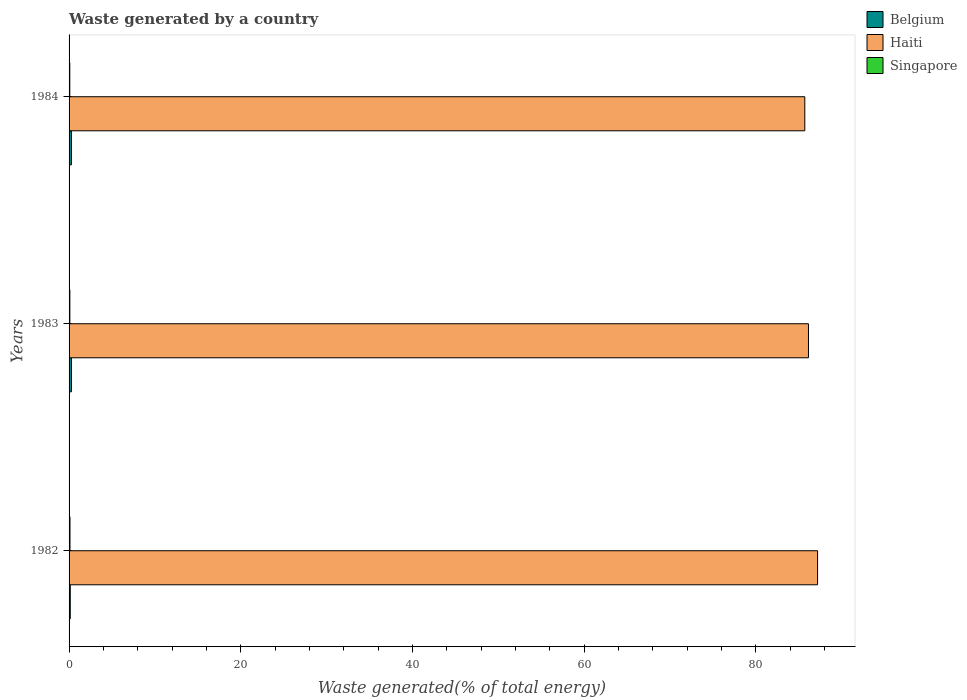How many groups of bars are there?
Offer a very short reply. 3. How many bars are there on the 3rd tick from the top?
Your answer should be compact. 3. How many bars are there on the 2nd tick from the bottom?
Make the answer very short. 3. What is the total waste generated in Belgium in 1984?
Ensure brevity in your answer.  0.27. Across all years, what is the maximum total waste generated in Haiti?
Your answer should be very brief. 87.19. Across all years, what is the minimum total waste generated in Belgium?
Give a very brief answer. 0.14. In which year was the total waste generated in Haiti maximum?
Your answer should be very brief. 1982. What is the total total waste generated in Haiti in the graph?
Provide a short and direct response. 259.02. What is the difference between the total waste generated in Belgium in 1982 and that in 1983?
Provide a succinct answer. -0.14. What is the difference between the total waste generated in Singapore in 1984 and the total waste generated in Haiti in 1982?
Provide a short and direct response. -87.11. What is the average total waste generated in Belgium per year?
Offer a very short reply. 0.23. In the year 1982, what is the difference between the total waste generated in Haiti and total waste generated in Singapore?
Your response must be concise. 87.08. What is the ratio of the total waste generated in Belgium in 1982 to that in 1984?
Your answer should be compact. 0.51. Is the difference between the total waste generated in Haiti in 1982 and 1983 greater than the difference between the total waste generated in Singapore in 1982 and 1983?
Your response must be concise. Yes. What is the difference between the highest and the second highest total waste generated in Belgium?
Your answer should be compact. 0. What is the difference between the highest and the lowest total waste generated in Singapore?
Ensure brevity in your answer.  0.02. What does the 3rd bar from the bottom in 1984 represents?
Ensure brevity in your answer.  Singapore. How many bars are there?
Provide a succinct answer. 9. Are all the bars in the graph horizontal?
Make the answer very short. Yes. Does the graph contain any zero values?
Give a very brief answer. No. Does the graph contain grids?
Ensure brevity in your answer.  No. How are the legend labels stacked?
Your answer should be compact. Vertical. What is the title of the graph?
Offer a very short reply. Waste generated by a country. Does "Micronesia" appear as one of the legend labels in the graph?
Provide a succinct answer. No. What is the label or title of the X-axis?
Offer a very short reply. Waste generated(% of total energy). What is the Waste generated(% of total energy) of Belgium in 1982?
Ensure brevity in your answer.  0.14. What is the Waste generated(% of total energy) in Haiti in 1982?
Your answer should be compact. 87.19. What is the Waste generated(% of total energy) of Singapore in 1982?
Provide a short and direct response. 0.11. What is the Waste generated(% of total energy) of Belgium in 1983?
Offer a terse response. 0.28. What is the Waste generated(% of total energy) of Haiti in 1983?
Make the answer very short. 86.13. What is the Waste generated(% of total energy) in Singapore in 1983?
Ensure brevity in your answer.  0.09. What is the Waste generated(% of total energy) of Belgium in 1984?
Give a very brief answer. 0.27. What is the Waste generated(% of total energy) in Haiti in 1984?
Keep it short and to the point. 85.7. What is the Waste generated(% of total energy) of Singapore in 1984?
Make the answer very short. 0.08. Across all years, what is the maximum Waste generated(% of total energy) of Belgium?
Offer a very short reply. 0.28. Across all years, what is the maximum Waste generated(% of total energy) in Haiti?
Your answer should be very brief. 87.19. Across all years, what is the maximum Waste generated(% of total energy) of Singapore?
Provide a short and direct response. 0.11. Across all years, what is the minimum Waste generated(% of total energy) in Belgium?
Ensure brevity in your answer.  0.14. Across all years, what is the minimum Waste generated(% of total energy) of Haiti?
Ensure brevity in your answer.  85.7. Across all years, what is the minimum Waste generated(% of total energy) of Singapore?
Offer a very short reply. 0.08. What is the total Waste generated(% of total energy) of Belgium in the graph?
Offer a very short reply. 0.69. What is the total Waste generated(% of total energy) in Haiti in the graph?
Offer a very short reply. 259.02. What is the total Waste generated(% of total energy) of Singapore in the graph?
Your answer should be compact. 0.28. What is the difference between the Waste generated(% of total energy) in Belgium in 1982 and that in 1983?
Your answer should be very brief. -0.14. What is the difference between the Waste generated(% of total energy) in Haiti in 1982 and that in 1983?
Offer a terse response. 1.06. What is the difference between the Waste generated(% of total energy) of Singapore in 1982 and that in 1983?
Keep it short and to the point. 0.01. What is the difference between the Waste generated(% of total energy) in Belgium in 1982 and that in 1984?
Provide a succinct answer. -0.14. What is the difference between the Waste generated(% of total energy) in Haiti in 1982 and that in 1984?
Your answer should be compact. 1.49. What is the difference between the Waste generated(% of total energy) in Singapore in 1982 and that in 1984?
Keep it short and to the point. 0.02. What is the difference between the Waste generated(% of total energy) of Belgium in 1983 and that in 1984?
Offer a terse response. 0. What is the difference between the Waste generated(% of total energy) of Haiti in 1983 and that in 1984?
Make the answer very short. 0.43. What is the difference between the Waste generated(% of total energy) of Singapore in 1983 and that in 1984?
Give a very brief answer. 0.01. What is the difference between the Waste generated(% of total energy) of Belgium in 1982 and the Waste generated(% of total energy) of Haiti in 1983?
Provide a short and direct response. -85.99. What is the difference between the Waste generated(% of total energy) of Belgium in 1982 and the Waste generated(% of total energy) of Singapore in 1983?
Offer a very short reply. 0.05. What is the difference between the Waste generated(% of total energy) of Haiti in 1982 and the Waste generated(% of total energy) of Singapore in 1983?
Give a very brief answer. 87.1. What is the difference between the Waste generated(% of total energy) in Belgium in 1982 and the Waste generated(% of total energy) in Haiti in 1984?
Offer a very short reply. -85.56. What is the difference between the Waste generated(% of total energy) in Belgium in 1982 and the Waste generated(% of total energy) in Singapore in 1984?
Make the answer very short. 0.06. What is the difference between the Waste generated(% of total energy) in Haiti in 1982 and the Waste generated(% of total energy) in Singapore in 1984?
Make the answer very short. 87.11. What is the difference between the Waste generated(% of total energy) in Belgium in 1983 and the Waste generated(% of total energy) in Haiti in 1984?
Ensure brevity in your answer.  -85.42. What is the difference between the Waste generated(% of total energy) of Belgium in 1983 and the Waste generated(% of total energy) of Singapore in 1984?
Your response must be concise. 0.2. What is the difference between the Waste generated(% of total energy) in Haiti in 1983 and the Waste generated(% of total energy) in Singapore in 1984?
Offer a very short reply. 86.05. What is the average Waste generated(% of total energy) of Belgium per year?
Make the answer very short. 0.23. What is the average Waste generated(% of total energy) in Haiti per year?
Your answer should be very brief. 86.34. What is the average Waste generated(% of total energy) in Singapore per year?
Offer a very short reply. 0.09. In the year 1982, what is the difference between the Waste generated(% of total energy) in Belgium and Waste generated(% of total energy) in Haiti?
Your response must be concise. -87.05. In the year 1982, what is the difference between the Waste generated(% of total energy) in Belgium and Waste generated(% of total energy) in Singapore?
Offer a very short reply. 0.03. In the year 1982, what is the difference between the Waste generated(% of total energy) in Haiti and Waste generated(% of total energy) in Singapore?
Give a very brief answer. 87.08. In the year 1983, what is the difference between the Waste generated(% of total energy) of Belgium and Waste generated(% of total energy) of Haiti?
Your answer should be very brief. -85.85. In the year 1983, what is the difference between the Waste generated(% of total energy) of Belgium and Waste generated(% of total energy) of Singapore?
Provide a succinct answer. 0.19. In the year 1983, what is the difference between the Waste generated(% of total energy) of Haiti and Waste generated(% of total energy) of Singapore?
Keep it short and to the point. 86.04. In the year 1984, what is the difference between the Waste generated(% of total energy) of Belgium and Waste generated(% of total energy) of Haiti?
Ensure brevity in your answer.  -85.43. In the year 1984, what is the difference between the Waste generated(% of total energy) of Belgium and Waste generated(% of total energy) of Singapore?
Your answer should be very brief. 0.19. In the year 1984, what is the difference between the Waste generated(% of total energy) in Haiti and Waste generated(% of total energy) in Singapore?
Make the answer very short. 85.62. What is the ratio of the Waste generated(% of total energy) of Belgium in 1982 to that in 1983?
Your response must be concise. 0.5. What is the ratio of the Waste generated(% of total energy) of Haiti in 1982 to that in 1983?
Keep it short and to the point. 1.01. What is the ratio of the Waste generated(% of total energy) of Singapore in 1982 to that in 1983?
Make the answer very short. 1.16. What is the ratio of the Waste generated(% of total energy) of Belgium in 1982 to that in 1984?
Provide a succinct answer. 0.51. What is the ratio of the Waste generated(% of total energy) in Haiti in 1982 to that in 1984?
Offer a very short reply. 1.02. What is the ratio of the Waste generated(% of total energy) in Singapore in 1982 to that in 1984?
Offer a terse response. 1.28. What is the ratio of the Waste generated(% of total energy) of Belgium in 1983 to that in 1984?
Offer a terse response. 1.01. What is the ratio of the Waste generated(% of total energy) in Singapore in 1983 to that in 1984?
Offer a very short reply. 1.1. What is the difference between the highest and the second highest Waste generated(% of total energy) in Belgium?
Provide a succinct answer. 0. What is the difference between the highest and the second highest Waste generated(% of total energy) of Haiti?
Offer a very short reply. 1.06. What is the difference between the highest and the second highest Waste generated(% of total energy) of Singapore?
Make the answer very short. 0.01. What is the difference between the highest and the lowest Waste generated(% of total energy) in Belgium?
Make the answer very short. 0.14. What is the difference between the highest and the lowest Waste generated(% of total energy) of Haiti?
Ensure brevity in your answer.  1.49. What is the difference between the highest and the lowest Waste generated(% of total energy) in Singapore?
Keep it short and to the point. 0.02. 